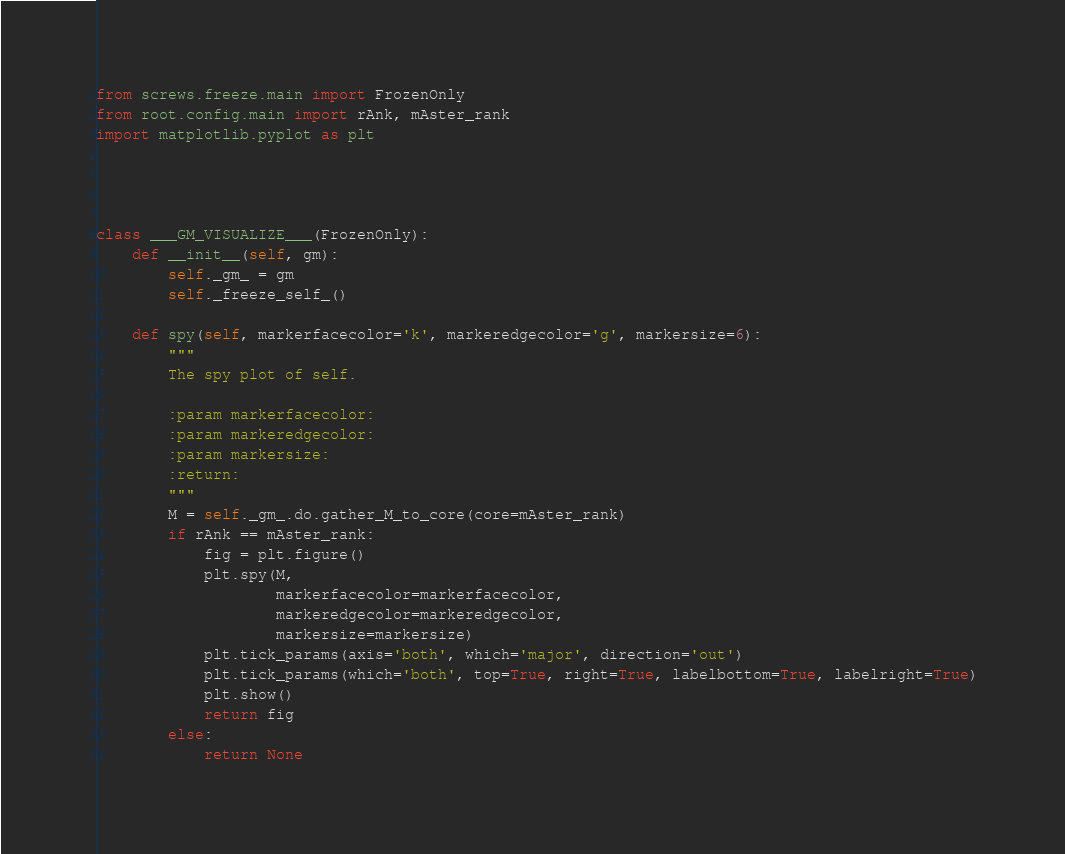<code> <loc_0><loc_0><loc_500><loc_500><_Python_>




from screws.freeze.main import FrozenOnly
from root.config.main import rAnk, mAster_rank
import matplotlib.pyplot as plt




class ___GM_VISUALIZE___(FrozenOnly):
    def __init__(self, gm):
        self._gm_ = gm
        self._freeze_self_()

    def spy(self, markerfacecolor='k', markeredgecolor='g', markersize=6):
        """
        The spy plot of self.

        :param markerfacecolor:
        :param markeredgecolor:
        :param markersize:
        :return:
        """
        M = self._gm_.do.gather_M_to_core(core=mAster_rank)
        if rAnk == mAster_rank:
            fig = plt.figure()
            plt.spy(M,
                    markerfacecolor=markerfacecolor,
                    markeredgecolor=markeredgecolor,
                    markersize=markersize)
            plt.tick_params(axis='both', which='major', direction='out')
            plt.tick_params(which='both', top=True, right=True, labelbottom=True, labelright=True)
            plt.show()
            return fig
        else:
            return None

</code> 